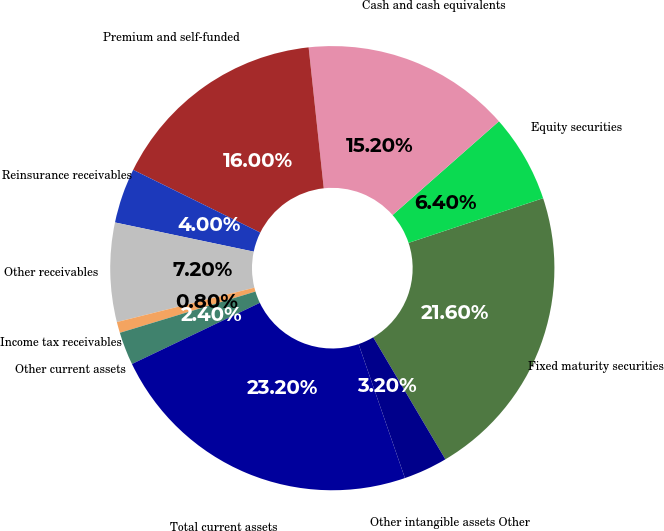Convert chart. <chart><loc_0><loc_0><loc_500><loc_500><pie_chart><fcel>Fixed maturity securities<fcel>Equity securities<fcel>Cash and cash equivalents<fcel>Premium and self-funded<fcel>Reinsurance receivables<fcel>Other receivables<fcel>Income tax receivables<fcel>Other current assets<fcel>Total current assets<fcel>Other intangible assets Other<nl><fcel>21.6%<fcel>6.4%<fcel>15.2%<fcel>16.0%<fcel>4.0%<fcel>7.2%<fcel>0.8%<fcel>2.4%<fcel>23.2%<fcel>3.2%<nl></chart> 